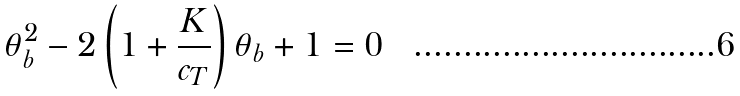Convert formula to latex. <formula><loc_0><loc_0><loc_500><loc_500>\theta _ { b } ^ { 2 } - 2 \left ( 1 + \frac { K } { c _ { T } } \right ) \theta _ { b } + 1 = 0</formula> 